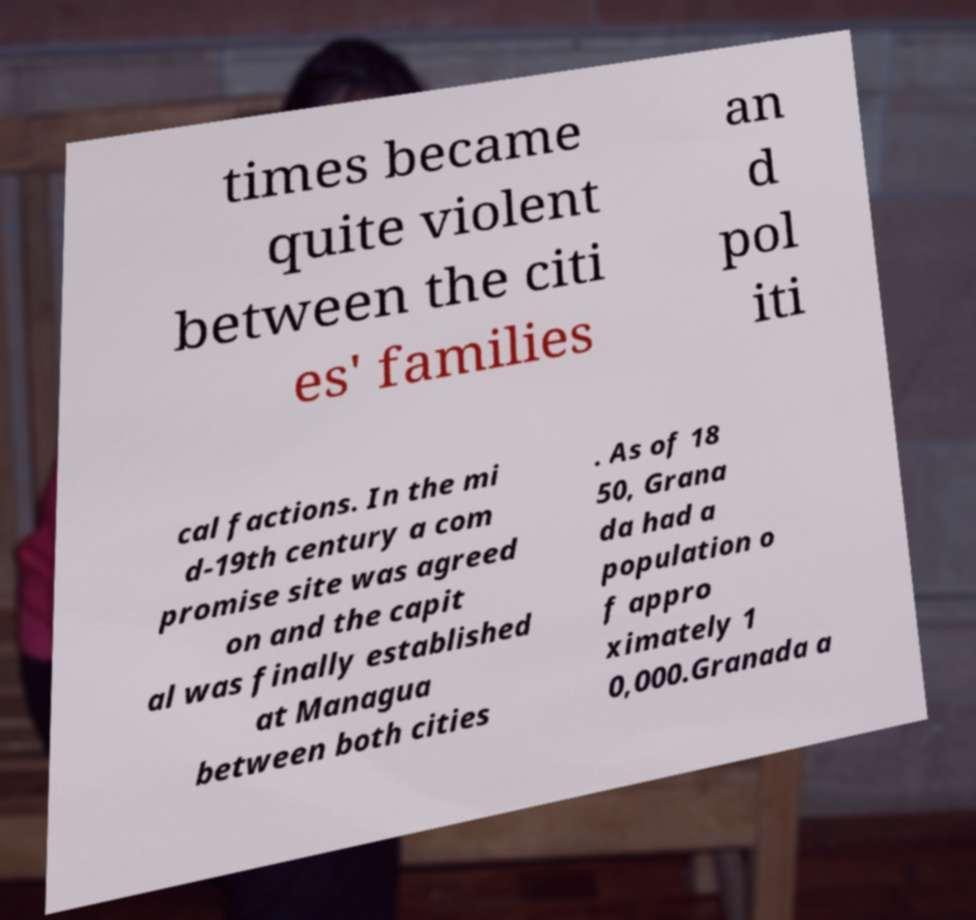Please identify and transcribe the text found in this image. times became quite violent between the citi es' families an d pol iti cal factions. In the mi d-19th century a com promise site was agreed on and the capit al was finally established at Managua between both cities . As of 18 50, Grana da had a population o f appro ximately 1 0,000.Granada a 